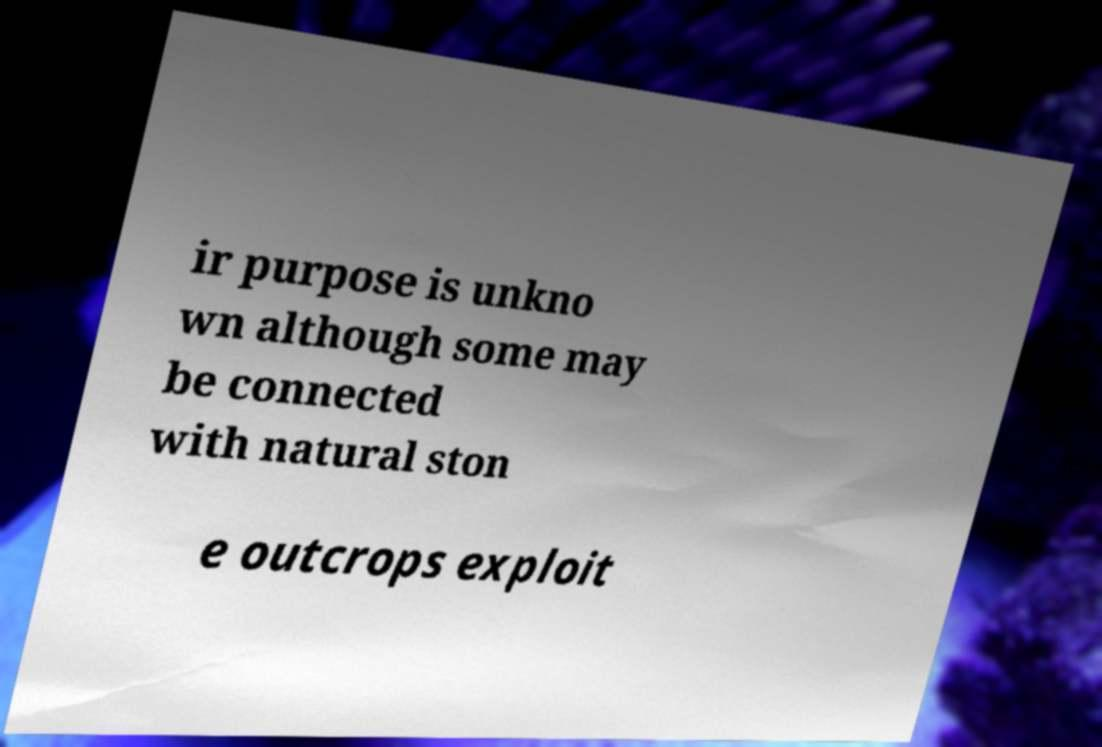For documentation purposes, I need the text within this image transcribed. Could you provide that? ir purpose is unkno wn although some may be connected with natural ston e outcrops exploit 